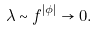<formula> <loc_0><loc_0><loc_500><loc_500>\lambda \sim f ^ { | \phi | } \rightarrow 0 .</formula> 